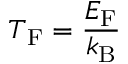<formula> <loc_0><loc_0><loc_500><loc_500>T _ { F } = { \frac { E _ { F } } { k _ { B } } }</formula> 